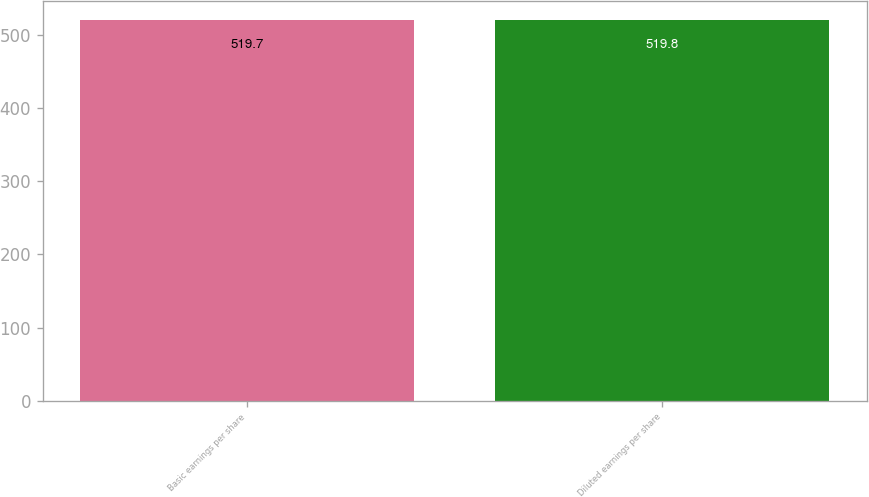Convert chart to OTSL. <chart><loc_0><loc_0><loc_500><loc_500><bar_chart><fcel>Basic earnings per share<fcel>Diluted earnings per share<nl><fcel>519.7<fcel>519.8<nl></chart> 